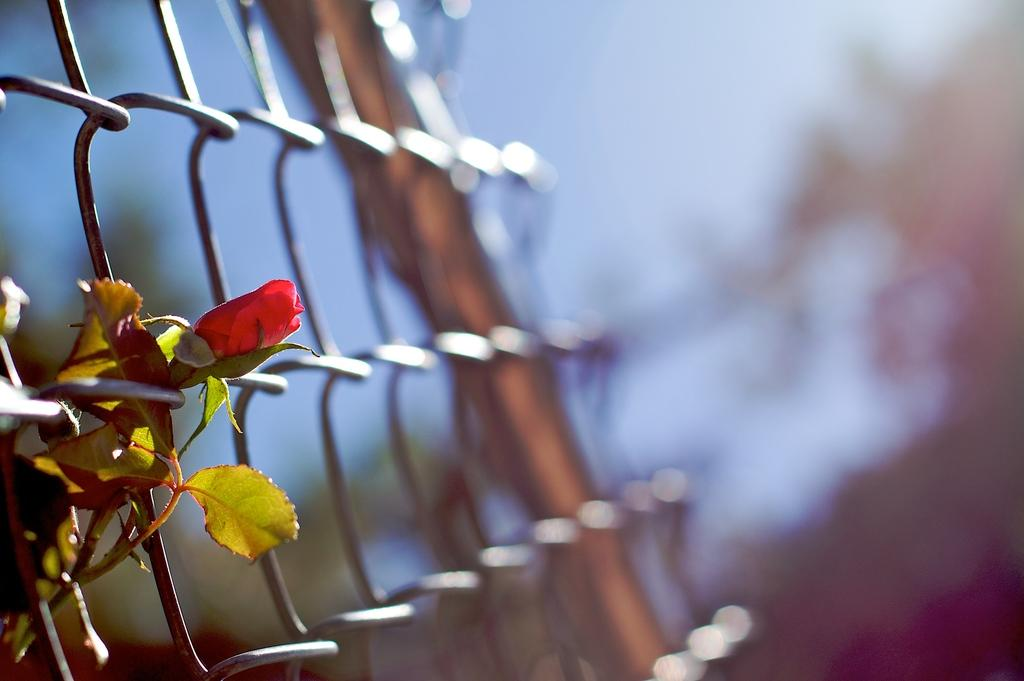What is located on the left side of the image? There is a fence on the left side of the image. What type of plant can be seen in the image? There is a plant with a red flower in the image. Can you describe the background of the image? The background of the image is blurred. What language is the plant speaking in the image? Plants do not speak languages, so this question cannot be answered. How many ears can be seen on the fence in the image? There are no ears present in the image; it features a fence and a plant with a red flower. 